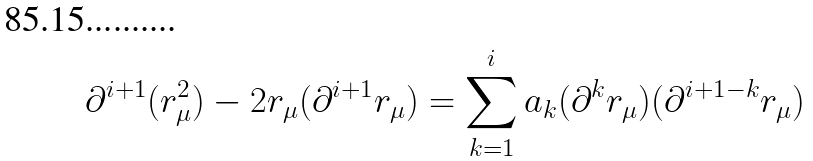Convert formula to latex. <formula><loc_0><loc_0><loc_500><loc_500>\partial ^ { i + 1 } ( r _ { \mu } ^ { 2 } ) - 2 r _ { \mu } ( \partial ^ { i + 1 } r _ { \mu } ) = \sum _ { k = 1 } ^ { i } a _ { k } ( \partial ^ { k } r _ { \mu } ) ( \partial ^ { i + 1 - k } r _ { \mu } )</formula> 